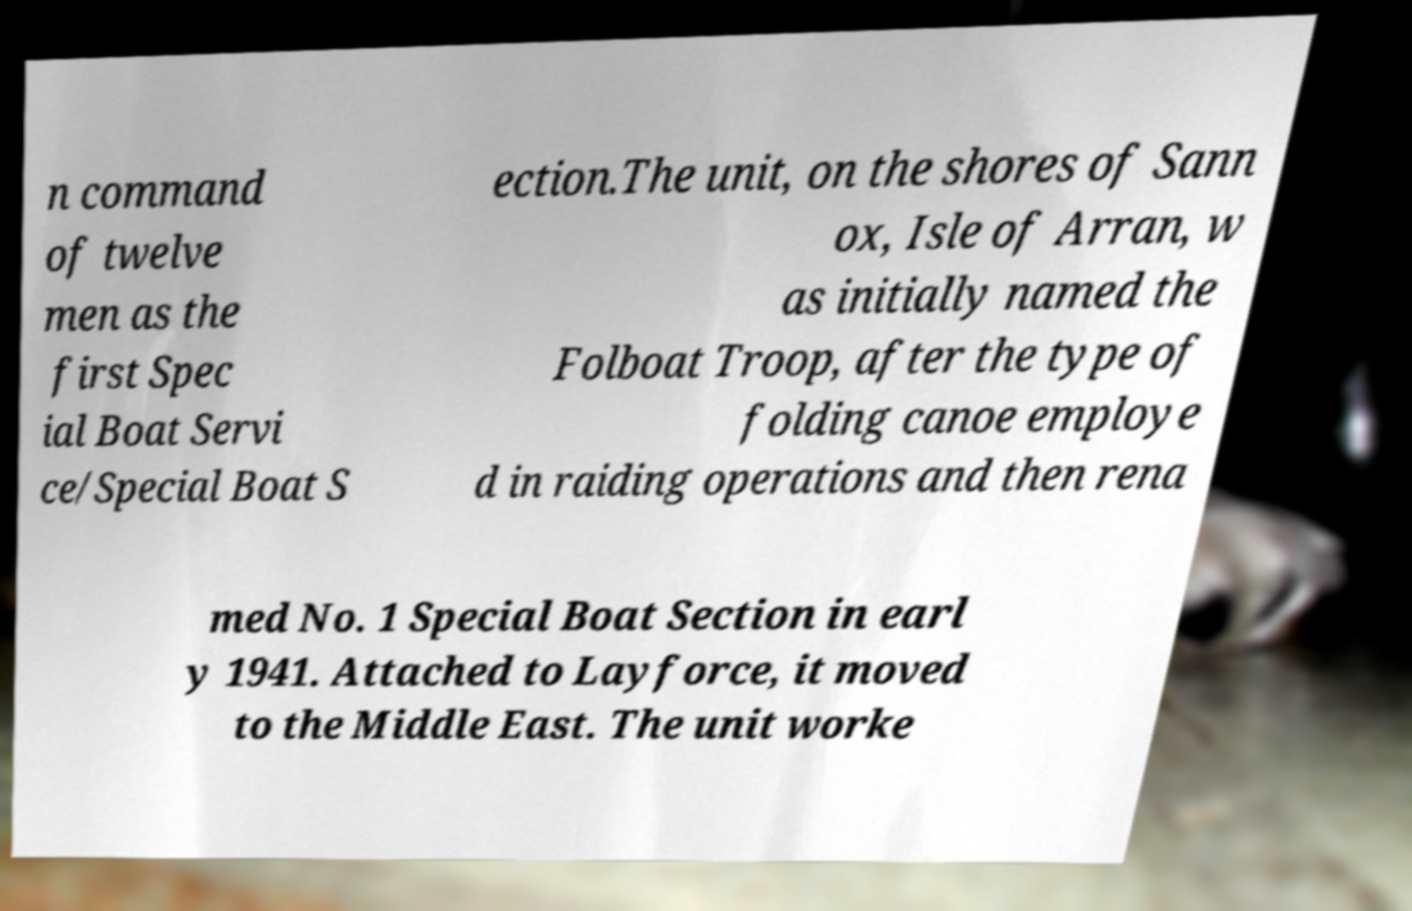What messages or text are displayed in this image? I need them in a readable, typed format. n command of twelve men as the first Spec ial Boat Servi ce/Special Boat S ection.The unit, on the shores of Sann ox, Isle of Arran, w as initially named the Folboat Troop, after the type of folding canoe employe d in raiding operations and then rena med No. 1 Special Boat Section in earl y 1941. Attached to Layforce, it moved to the Middle East. The unit worke 